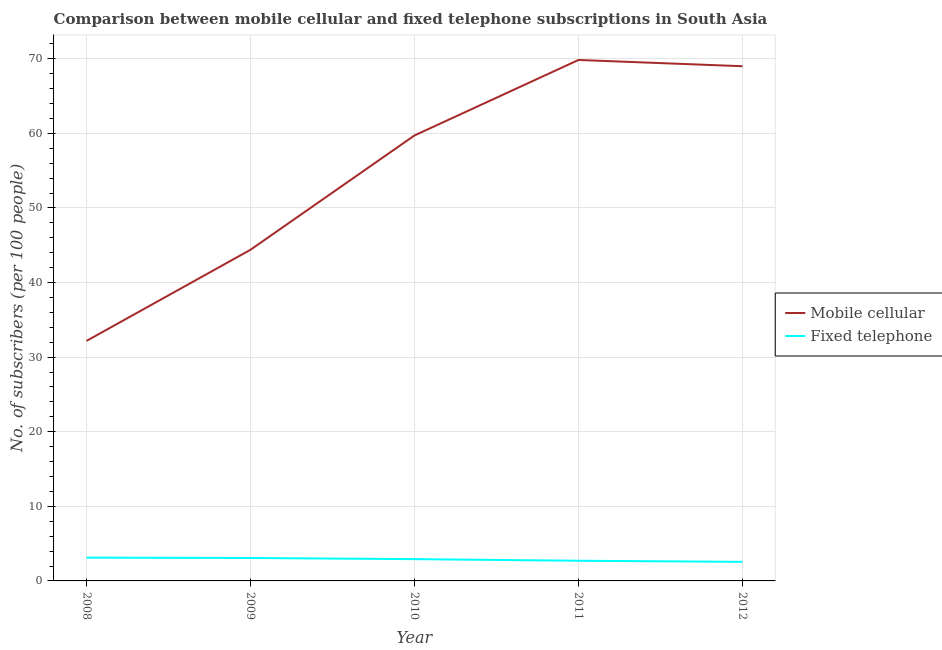Does the line corresponding to number of mobile cellular subscribers intersect with the line corresponding to number of fixed telephone subscribers?
Provide a short and direct response. No. What is the number of fixed telephone subscribers in 2010?
Your answer should be compact. 2.92. Across all years, what is the maximum number of mobile cellular subscribers?
Your response must be concise. 69.84. Across all years, what is the minimum number of mobile cellular subscribers?
Offer a terse response. 32.18. In which year was the number of fixed telephone subscribers maximum?
Your answer should be very brief. 2008. What is the total number of mobile cellular subscribers in the graph?
Offer a very short reply. 275.16. What is the difference between the number of fixed telephone subscribers in 2008 and that in 2010?
Ensure brevity in your answer.  0.2. What is the difference between the number of mobile cellular subscribers in 2012 and the number of fixed telephone subscribers in 2011?
Make the answer very short. 66.3. What is the average number of fixed telephone subscribers per year?
Your response must be concise. 2.88. In the year 2012, what is the difference between the number of fixed telephone subscribers and number of mobile cellular subscribers?
Keep it short and to the point. -66.45. In how many years, is the number of fixed telephone subscribers greater than 60?
Provide a succinct answer. 0. What is the ratio of the number of fixed telephone subscribers in 2008 to that in 2009?
Offer a very short reply. 1.02. Is the number of mobile cellular subscribers in 2009 less than that in 2012?
Offer a terse response. Yes. Is the difference between the number of fixed telephone subscribers in 2010 and 2012 greater than the difference between the number of mobile cellular subscribers in 2010 and 2012?
Offer a very short reply. Yes. What is the difference between the highest and the second highest number of mobile cellular subscribers?
Your response must be concise. 0.84. What is the difference between the highest and the lowest number of fixed telephone subscribers?
Your answer should be compact. 0.56. How many lines are there?
Offer a terse response. 2. How many years are there in the graph?
Ensure brevity in your answer.  5. Are the values on the major ticks of Y-axis written in scientific E-notation?
Make the answer very short. No. How are the legend labels stacked?
Your answer should be compact. Vertical. What is the title of the graph?
Your answer should be compact. Comparison between mobile cellular and fixed telephone subscriptions in South Asia. Does "External balance on goods" appear as one of the legend labels in the graph?
Provide a succinct answer. No. What is the label or title of the X-axis?
Offer a terse response. Year. What is the label or title of the Y-axis?
Your answer should be very brief. No. of subscribers (per 100 people). What is the No. of subscribers (per 100 people) of Mobile cellular in 2008?
Your response must be concise. 32.18. What is the No. of subscribers (per 100 people) in Fixed telephone in 2008?
Ensure brevity in your answer.  3.12. What is the No. of subscribers (per 100 people) of Mobile cellular in 2009?
Keep it short and to the point. 44.4. What is the No. of subscribers (per 100 people) in Fixed telephone in 2009?
Make the answer very short. 3.07. What is the No. of subscribers (per 100 people) of Mobile cellular in 2010?
Keep it short and to the point. 59.72. What is the No. of subscribers (per 100 people) of Fixed telephone in 2010?
Provide a short and direct response. 2.92. What is the No. of subscribers (per 100 people) in Mobile cellular in 2011?
Ensure brevity in your answer.  69.84. What is the No. of subscribers (per 100 people) of Fixed telephone in 2011?
Keep it short and to the point. 2.71. What is the No. of subscribers (per 100 people) in Mobile cellular in 2012?
Provide a succinct answer. 69.01. What is the No. of subscribers (per 100 people) in Fixed telephone in 2012?
Offer a terse response. 2.56. Across all years, what is the maximum No. of subscribers (per 100 people) in Mobile cellular?
Your response must be concise. 69.84. Across all years, what is the maximum No. of subscribers (per 100 people) in Fixed telephone?
Make the answer very short. 3.12. Across all years, what is the minimum No. of subscribers (per 100 people) in Mobile cellular?
Provide a succinct answer. 32.18. Across all years, what is the minimum No. of subscribers (per 100 people) of Fixed telephone?
Provide a short and direct response. 2.56. What is the total No. of subscribers (per 100 people) of Mobile cellular in the graph?
Provide a short and direct response. 275.16. What is the total No. of subscribers (per 100 people) in Fixed telephone in the graph?
Provide a short and direct response. 14.38. What is the difference between the No. of subscribers (per 100 people) in Mobile cellular in 2008 and that in 2009?
Make the answer very short. -12.22. What is the difference between the No. of subscribers (per 100 people) in Fixed telephone in 2008 and that in 2009?
Your answer should be compact. 0.05. What is the difference between the No. of subscribers (per 100 people) of Mobile cellular in 2008 and that in 2010?
Your answer should be very brief. -27.54. What is the difference between the No. of subscribers (per 100 people) of Fixed telephone in 2008 and that in 2010?
Your response must be concise. 0.2. What is the difference between the No. of subscribers (per 100 people) of Mobile cellular in 2008 and that in 2011?
Offer a terse response. -37.66. What is the difference between the No. of subscribers (per 100 people) in Fixed telephone in 2008 and that in 2011?
Your response must be concise. 0.42. What is the difference between the No. of subscribers (per 100 people) of Mobile cellular in 2008 and that in 2012?
Offer a very short reply. -36.83. What is the difference between the No. of subscribers (per 100 people) in Fixed telephone in 2008 and that in 2012?
Your answer should be compact. 0.56. What is the difference between the No. of subscribers (per 100 people) of Mobile cellular in 2009 and that in 2010?
Your response must be concise. -15.33. What is the difference between the No. of subscribers (per 100 people) in Fixed telephone in 2009 and that in 2010?
Keep it short and to the point. 0.15. What is the difference between the No. of subscribers (per 100 people) in Mobile cellular in 2009 and that in 2011?
Your answer should be very brief. -25.45. What is the difference between the No. of subscribers (per 100 people) in Fixed telephone in 2009 and that in 2011?
Offer a very short reply. 0.37. What is the difference between the No. of subscribers (per 100 people) in Mobile cellular in 2009 and that in 2012?
Make the answer very short. -24.61. What is the difference between the No. of subscribers (per 100 people) of Fixed telephone in 2009 and that in 2012?
Offer a terse response. 0.52. What is the difference between the No. of subscribers (per 100 people) of Mobile cellular in 2010 and that in 2011?
Keep it short and to the point. -10.12. What is the difference between the No. of subscribers (per 100 people) in Fixed telephone in 2010 and that in 2011?
Your answer should be compact. 0.22. What is the difference between the No. of subscribers (per 100 people) of Mobile cellular in 2010 and that in 2012?
Keep it short and to the point. -9.28. What is the difference between the No. of subscribers (per 100 people) in Fixed telephone in 2010 and that in 2012?
Keep it short and to the point. 0.36. What is the difference between the No. of subscribers (per 100 people) in Mobile cellular in 2011 and that in 2012?
Offer a terse response. 0.84. What is the difference between the No. of subscribers (per 100 people) of Fixed telephone in 2011 and that in 2012?
Your answer should be very brief. 0.15. What is the difference between the No. of subscribers (per 100 people) in Mobile cellular in 2008 and the No. of subscribers (per 100 people) in Fixed telephone in 2009?
Offer a very short reply. 29.11. What is the difference between the No. of subscribers (per 100 people) of Mobile cellular in 2008 and the No. of subscribers (per 100 people) of Fixed telephone in 2010?
Offer a very short reply. 29.26. What is the difference between the No. of subscribers (per 100 people) of Mobile cellular in 2008 and the No. of subscribers (per 100 people) of Fixed telephone in 2011?
Provide a succinct answer. 29.47. What is the difference between the No. of subscribers (per 100 people) in Mobile cellular in 2008 and the No. of subscribers (per 100 people) in Fixed telephone in 2012?
Make the answer very short. 29.62. What is the difference between the No. of subscribers (per 100 people) in Mobile cellular in 2009 and the No. of subscribers (per 100 people) in Fixed telephone in 2010?
Give a very brief answer. 41.48. What is the difference between the No. of subscribers (per 100 people) of Mobile cellular in 2009 and the No. of subscribers (per 100 people) of Fixed telephone in 2011?
Offer a terse response. 41.69. What is the difference between the No. of subscribers (per 100 people) in Mobile cellular in 2009 and the No. of subscribers (per 100 people) in Fixed telephone in 2012?
Your response must be concise. 41.84. What is the difference between the No. of subscribers (per 100 people) in Mobile cellular in 2010 and the No. of subscribers (per 100 people) in Fixed telephone in 2011?
Your answer should be very brief. 57.02. What is the difference between the No. of subscribers (per 100 people) of Mobile cellular in 2010 and the No. of subscribers (per 100 people) of Fixed telephone in 2012?
Offer a very short reply. 57.17. What is the difference between the No. of subscribers (per 100 people) of Mobile cellular in 2011 and the No. of subscribers (per 100 people) of Fixed telephone in 2012?
Your answer should be very brief. 67.29. What is the average No. of subscribers (per 100 people) of Mobile cellular per year?
Give a very brief answer. 55.03. What is the average No. of subscribers (per 100 people) in Fixed telephone per year?
Provide a short and direct response. 2.88. In the year 2008, what is the difference between the No. of subscribers (per 100 people) of Mobile cellular and No. of subscribers (per 100 people) of Fixed telephone?
Offer a terse response. 29.06. In the year 2009, what is the difference between the No. of subscribers (per 100 people) of Mobile cellular and No. of subscribers (per 100 people) of Fixed telephone?
Provide a succinct answer. 41.32. In the year 2010, what is the difference between the No. of subscribers (per 100 people) of Mobile cellular and No. of subscribers (per 100 people) of Fixed telephone?
Provide a short and direct response. 56.8. In the year 2011, what is the difference between the No. of subscribers (per 100 people) in Mobile cellular and No. of subscribers (per 100 people) in Fixed telephone?
Make the answer very short. 67.14. In the year 2012, what is the difference between the No. of subscribers (per 100 people) in Mobile cellular and No. of subscribers (per 100 people) in Fixed telephone?
Your answer should be very brief. 66.45. What is the ratio of the No. of subscribers (per 100 people) in Mobile cellular in 2008 to that in 2009?
Give a very brief answer. 0.72. What is the ratio of the No. of subscribers (per 100 people) of Fixed telephone in 2008 to that in 2009?
Your response must be concise. 1.02. What is the ratio of the No. of subscribers (per 100 people) of Mobile cellular in 2008 to that in 2010?
Your answer should be compact. 0.54. What is the ratio of the No. of subscribers (per 100 people) in Fixed telephone in 2008 to that in 2010?
Offer a very short reply. 1.07. What is the ratio of the No. of subscribers (per 100 people) in Mobile cellular in 2008 to that in 2011?
Give a very brief answer. 0.46. What is the ratio of the No. of subscribers (per 100 people) of Fixed telephone in 2008 to that in 2011?
Offer a very short reply. 1.15. What is the ratio of the No. of subscribers (per 100 people) of Mobile cellular in 2008 to that in 2012?
Offer a very short reply. 0.47. What is the ratio of the No. of subscribers (per 100 people) of Fixed telephone in 2008 to that in 2012?
Your answer should be very brief. 1.22. What is the ratio of the No. of subscribers (per 100 people) of Mobile cellular in 2009 to that in 2010?
Your answer should be very brief. 0.74. What is the ratio of the No. of subscribers (per 100 people) of Fixed telephone in 2009 to that in 2010?
Your answer should be compact. 1.05. What is the ratio of the No. of subscribers (per 100 people) of Mobile cellular in 2009 to that in 2011?
Give a very brief answer. 0.64. What is the ratio of the No. of subscribers (per 100 people) in Fixed telephone in 2009 to that in 2011?
Provide a succinct answer. 1.14. What is the ratio of the No. of subscribers (per 100 people) in Mobile cellular in 2009 to that in 2012?
Keep it short and to the point. 0.64. What is the ratio of the No. of subscribers (per 100 people) in Fixed telephone in 2009 to that in 2012?
Ensure brevity in your answer.  1.2. What is the ratio of the No. of subscribers (per 100 people) in Mobile cellular in 2010 to that in 2011?
Ensure brevity in your answer.  0.86. What is the ratio of the No. of subscribers (per 100 people) in Fixed telephone in 2010 to that in 2011?
Offer a terse response. 1.08. What is the ratio of the No. of subscribers (per 100 people) in Mobile cellular in 2010 to that in 2012?
Offer a terse response. 0.87. What is the ratio of the No. of subscribers (per 100 people) in Fixed telephone in 2010 to that in 2012?
Your answer should be very brief. 1.14. What is the ratio of the No. of subscribers (per 100 people) of Mobile cellular in 2011 to that in 2012?
Your answer should be compact. 1.01. What is the ratio of the No. of subscribers (per 100 people) of Fixed telephone in 2011 to that in 2012?
Keep it short and to the point. 1.06. What is the difference between the highest and the second highest No. of subscribers (per 100 people) of Mobile cellular?
Give a very brief answer. 0.84. What is the difference between the highest and the second highest No. of subscribers (per 100 people) in Fixed telephone?
Your answer should be very brief. 0.05. What is the difference between the highest and the lowest No. of subscribers (per 100 people) of Mobile cellular?
Provide a short and direct response. 37.66. What is the difference between the highest and the lowest No. of subscribers (per 100 people) in Fixed telephone?
Provide a succinct answer. 0.56. 